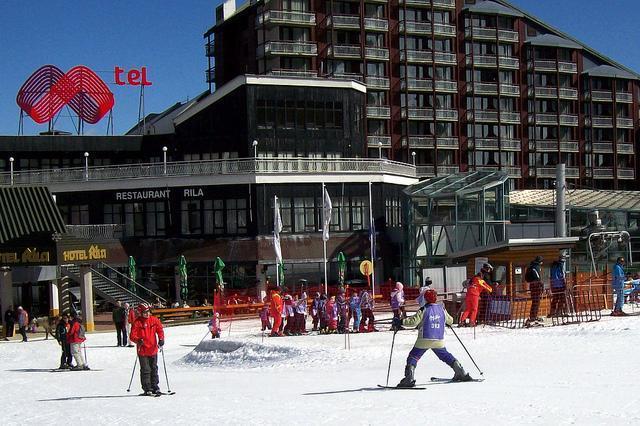How many people are in the photo?
Give a very brief answer. 3. How many adults giraffes in the picture?
Give a very brief answer. 0. 